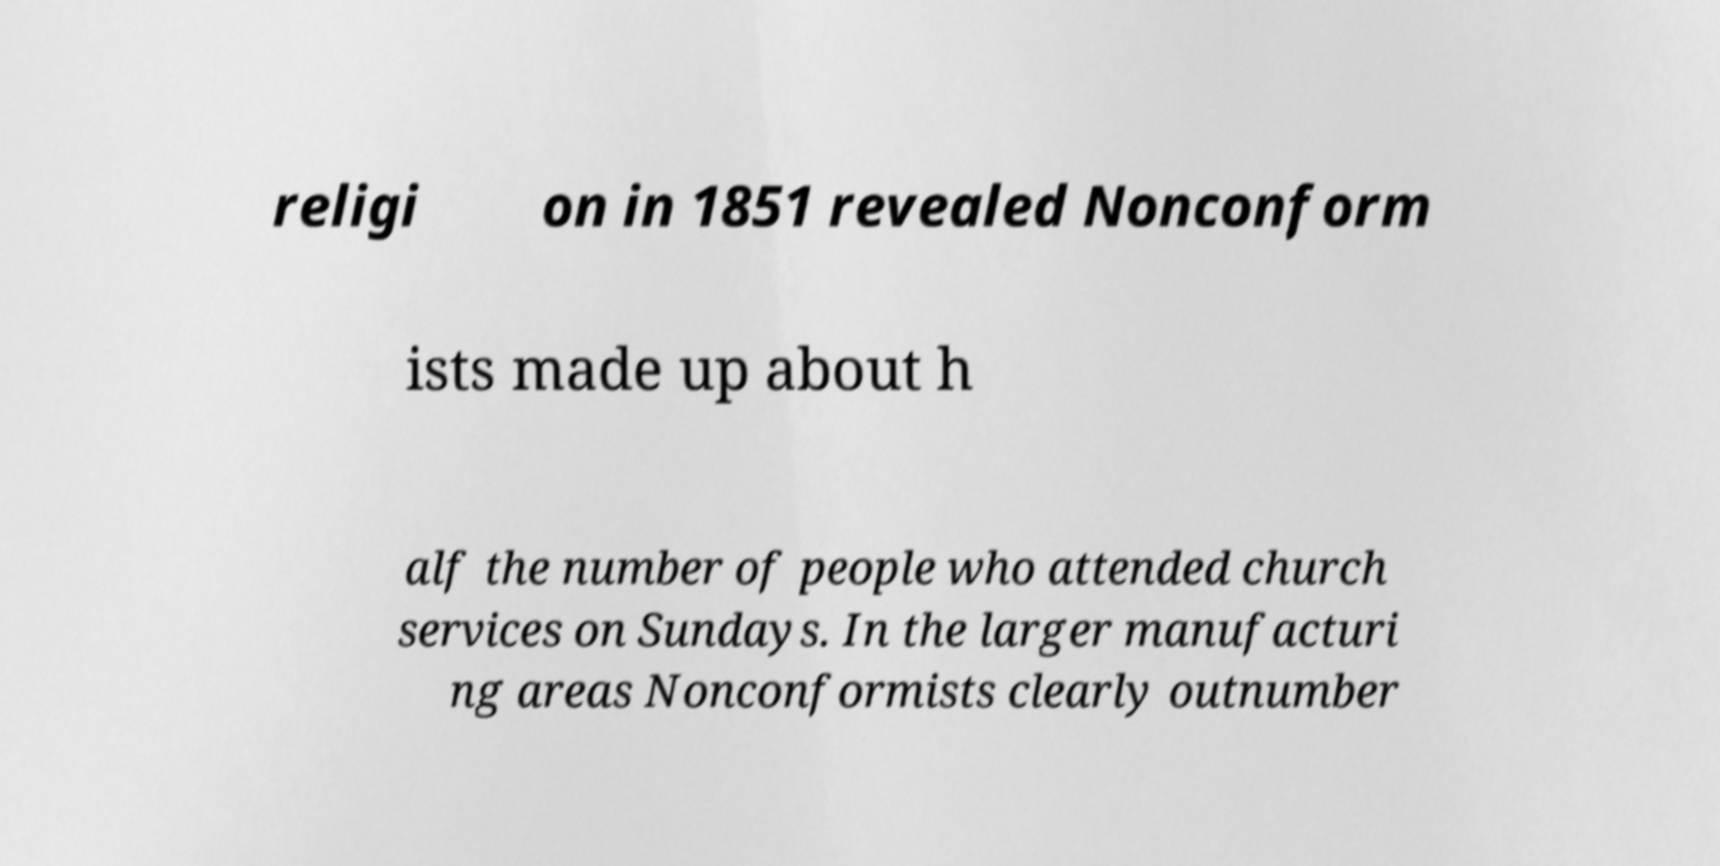Please read and relay the text visible in this image. What does it say? religi on in 1851 revealed Nonconform ists made up about h alf the number of people who attended church services on Sundays. In the larger manufacturi ng areas Nonconformists clearly outnumber 